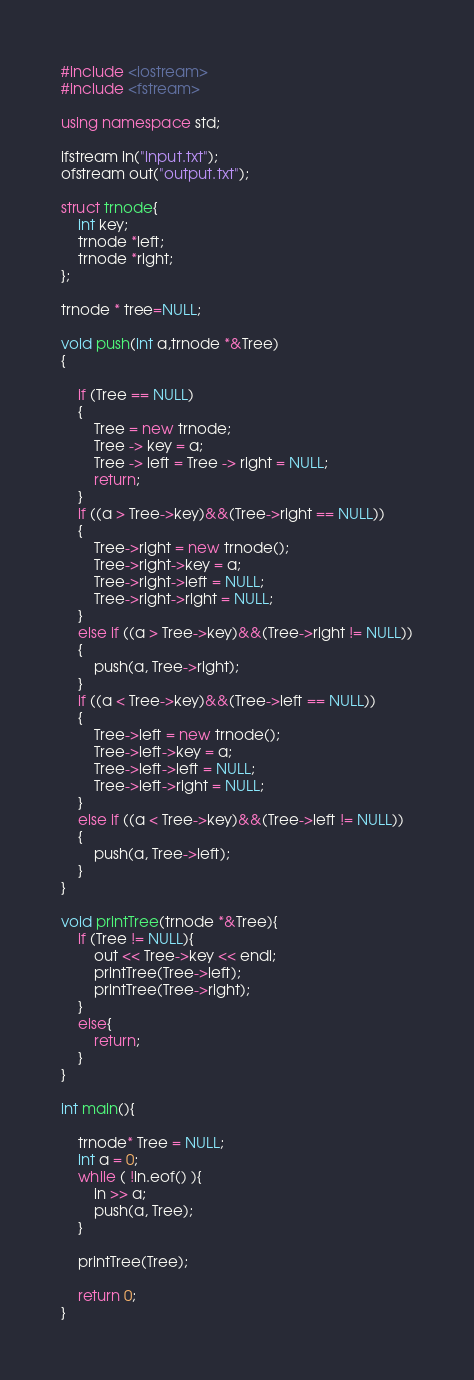Convert code to text. <code><loc_0><loc_0><loc_500><loc_500><_C++_>#include <iostream>
#include <fstream>

using namespace std;

ifstream in("input.txt");
ofstream out("output.txt");

struct trnode{
    int key;
    trnode *left;
    trnode *right;
};

trnode * tree=NULL;

void push(int a,trnode *&Tree)
{
    
    if (Tree == NULL)
    {
        Tree = new trnode;
        Tree -> key = a;
        Tree -> left = Tree -> right = NULL;
        return;
    }
    if ((a > Tree->key)&&(Tree->right == NULL))
    {
        Tree->right = new trnode();
        Tree->right->key = a;
        Tree->right->left = NULL;
        Tree->right->right = NULL;
    }
    else if ((a > Tree->key)&&(Tree->right != NULL))
    {
        push(a, Tree->right);
    }
    if ((a < Tree->key)&&(Tree->left == NULL))
    {
        Tree->left = new trnode();
        Tree->left->key = a;
        Tree->left->left = NULL;
        Tree->left->right = NULL;
    }
    else if ((a < Tree->key)&&(Tree->left != NULL))
    {
        push(a, Tree->left);
    }
}

void printTree(trnode *&Tree){
    if (Tree != NULL){
        out << Tree->key << endl;
        printTree(Tree->left);
        printTree(Tree->right);
    }
    else{
        return;
    }
}

int main(){
    
    trnode* Tree = NULL;
    int a = 0;
    while ( !in.eof() ){
        in >> a;
        push(a, Tree);
    }
    
    printTree(Tree);
    
    return 0;
}
</code> 